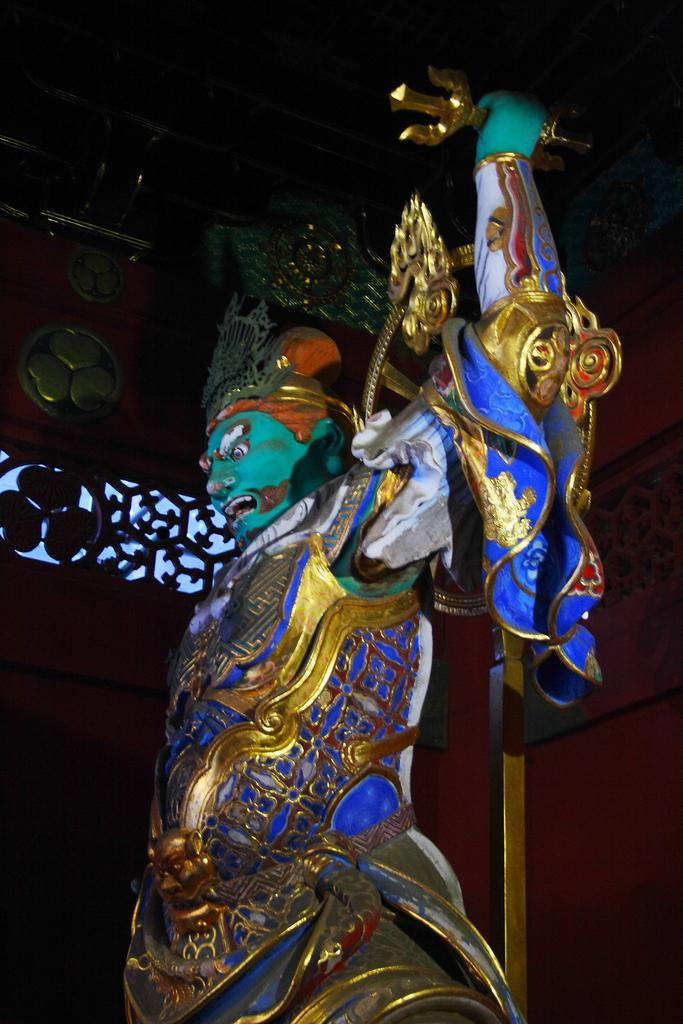What colors are used for the statue in the image? The statue is in blue and green colors. Can you see any spots on the statue's neck in the image? There is no mention of spots or a neck in the provided fact, and therefore we cannot determine their presence in the image. 